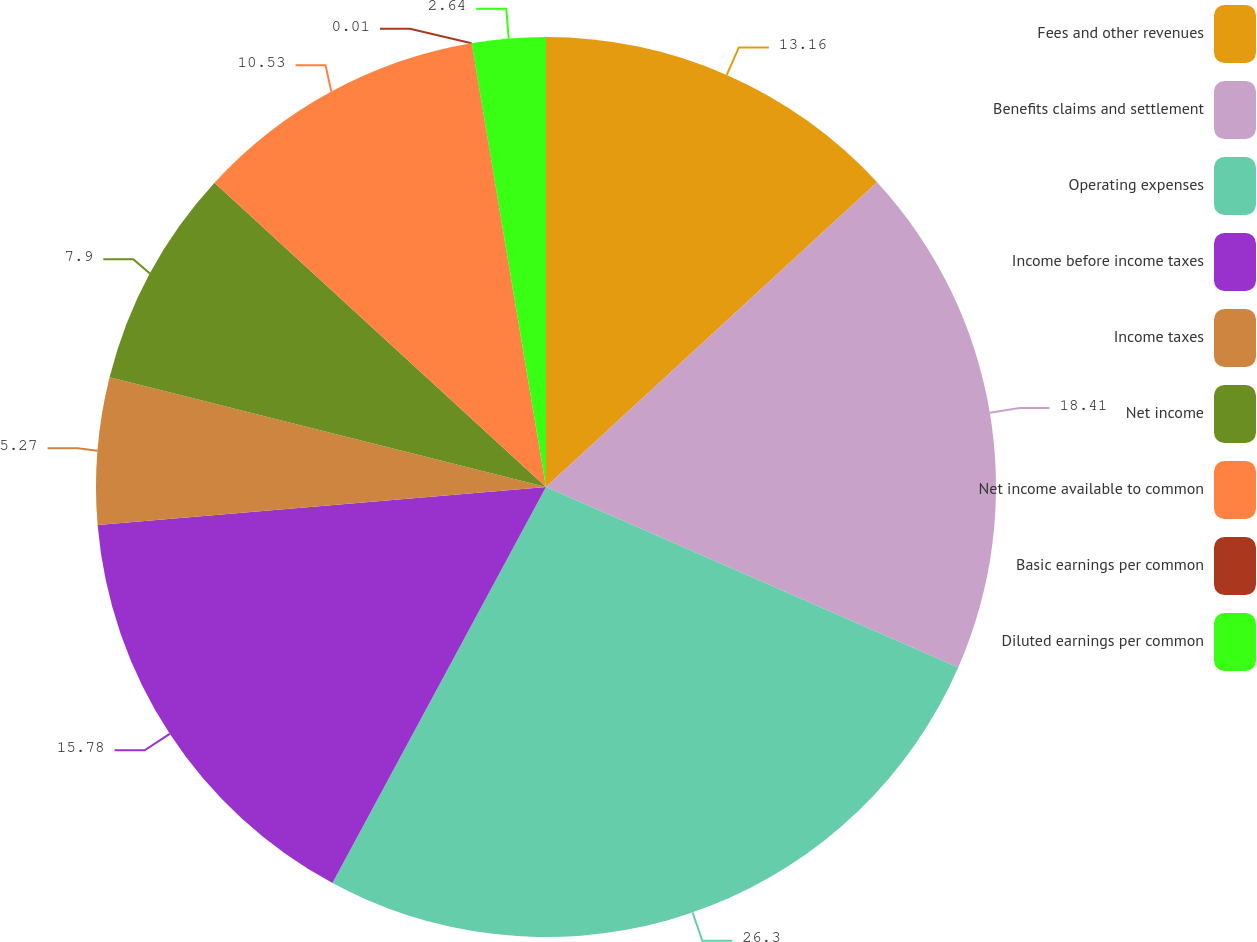Convert chart to OTSL. <chart><loc_0><loc_0><loc_500><loc_500><pie_chart><fcel>Fees and other revenues<fcel>Benefits claims and settlement<fcel>Operating expenses<fcel>Income before income taxes<fcel>Income taxes<fcel>Net income<fcel>Net income available to common<fcel>Basic earnings per common<fcel>Diluted earnings per common<nl><fcel>13.16%<fcel>18.41%<fcel>26.3%<fcel>15.78%<fcel>5.27%<fcel>7.9%<fcel>10.53%<fcel>0.01%<fcel>2.64%<nl></chart> 